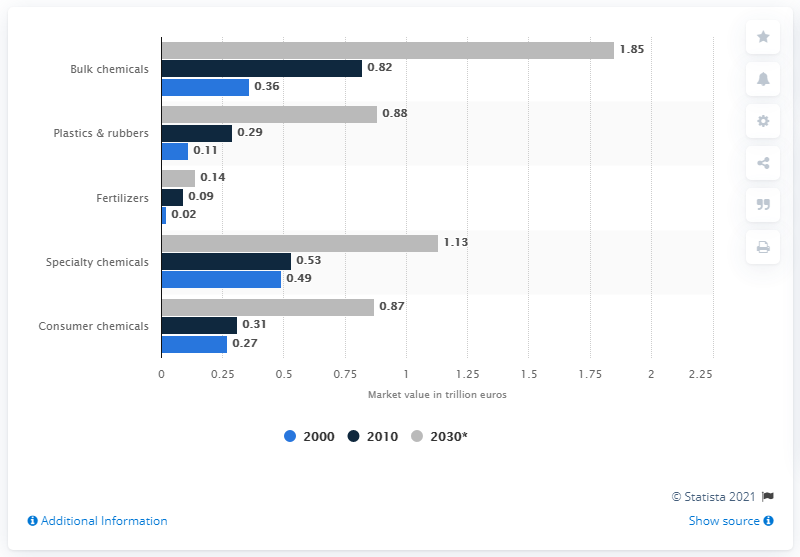Give some essential details in this illustration. In 2000, the value of the fertilizer chemical market was approximately 0.02. 